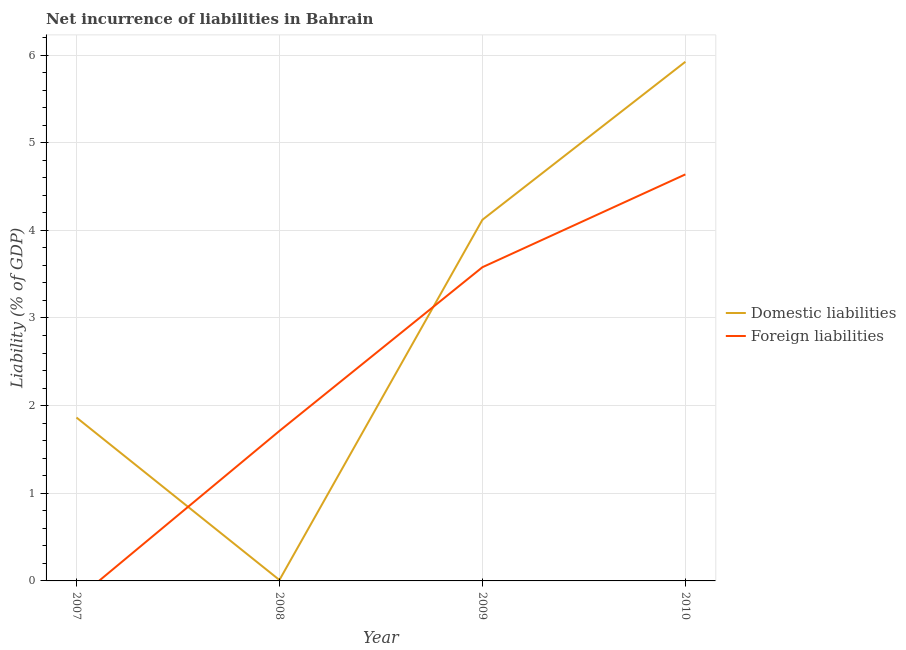How many different coloured lines are there?
Make the answer very short. 2. Does the line corresponding to incurrence of foreign liabilities intersect with the line corresponding to incurrence of domestic liabilities?
Your response must be concise. Yes. Is the number of lines equal to the number of legend labels?
Your response must be concise. No. What is the incurrence of domestic liabilities in 2007?
Provide a short and direct response. 1.86. Across all years, what is the maximum incurrence of domestic liabilities?
Offer a terse response. 5.92. Across all years, what is the minimum incurrence of domestic liabilities?
Your answer should be compact. 0.01. In which year was the incurrence of domestic liabilities maximum?
Ensure brevity in your answer.  2010. What is the total incurrence of domestic liabilities in the graph?
Your answer should be very brief. 11.92. What is the difference between the incurrence of foreign liabilities in 2009 and that in 2010?
Your answer should be very brief. -1.06. What is the difference between the incurrence of foreign liabilities in 2007 and the incurrence of domestic liabilities in 2010?
Offer a terse response. -5.92. What is the average incurrence of foreign liabilities per year?
Ensure brevity in your answer.  2.48. In the year 2010, what is the difference between the incurrence of foreign liabilities and incurrence of domestic liabilities?
Offer a terse response. -1.29. In how many years, is the incurrence of domestic liabilities greater than 1.4 %?
Provide a short and direct response. 3. What is the ratio of the incurrence of domestic liabilities in 2009 to that in 2010?
Your answer should be compact. 0.7. Is the incurrence of domestic liabilities in 2008 less than that in 2010?
Your response must be concise. Yes. Is the difference between the incurrence of domestic liabilities in 2009 and 2010 greater than the difference between the incurrence of foreign liabilities in 2009 and 2010?
Provide a succinct answer. No. What is the difference between the highest and the second highest incurrence of foreign liabilities?
Offer a very short reply. 1.06. What is the difference between the highest and the lowest incurrence of domestic liabilities?
Your answer should be compact. 5.91. Does the incurrence of domestic liabilities monotonically increase over the years?
Your answer should be compact. No. How many lines are there?
Your answer should be very brief. 2. How many years are there in the graph?
Offer a very short reply. 4. What is the difference between two consecutive major ticks on the Y-axis?
Your answer should be compact. 1. Does the graph contain any zero values?
Offer a very short reply. Yes. Where does the legend appear in the graph?
Your answer should be very brief. Center right. How are the legend labels stacked?
Offer a terse response. Vertical. What is the title of the graph?
Your answer should be compact. Net incurrence of liabilities in Bahrain. What is the label or title of the X-axis?
Provide a short and direct response. Year. What is the label or title of the Y-axis?
Provide a short and direct response. Liability (% of GDP). What is the Liability (% of GDP) of Domestic liabilities in 2007?
Offer a very short reply. 1.86. What is the Liability (% of GDP) of Foreign liabilities in 2007?
Provide a succinct answer. 0. What is the Liability (% of GDP) in Domestic liabilities in 2008?
Give a very brief answer. 0.01. What is the Liability (% of GDP) in Foreign liabilities in 2008?
Make the answer very short. 1.71. What is the Liability (% of GDP) of Domestic liabilities in 2009?
Make the answer very short. 4.12. What is the Liability (% of GDP) in Foreign liabilities in 2009?
Your response must be concise. 3.58. What is the Liability (% of GDP) in Domestic liabilities in 2010?
Provide a succinct answer. 5.92. What is the Liability (% of GDP) of Foreign liabilities in 2010?
Give a very brief answer. 4.64. Across all years, what is the maximum Liability (% of GDP) in Domestic liabilities?
Offer a terse response. 5.92. Across all years, what is the maximum Liability (% of GDP) of Foreign liabilities?
Your response must be concise. 4.64. Across all years, what is the minimum Liability (% of GDP) of Domestic liabilities?
Provide a short and direct response. 0.01. What is the total Liability (% of GDP) in Domestic liabilities in the graph?
Ensure brevity in your answer.  11.92. What is the total Liability (% of GDP) in Foreign liabilities in the graph?
Offer a very short reply. 9.93. What is the difference between the Liability (% of GDP) in Domestic liabilities in 2007 and that in 2008?
Give a very brief answer. 1.85. What is the difference between the Liability (% of GDP) of Domestic liabilities in 2007 and that in 2009?
Your answer should be very brief. -2.26. What is the difference between the Liability (% of GDP) of Domestic liabilities in 2007 and that in 2010?
Your response must be concise. -4.06. What is the difference between the Liability (% of GDP) in Domestic liabilities in 2008 and that in 2009?
Provide a succinct answer. -4.11. What is the difference between the Liability (% of GDP) in Foreign liabilities in 2008 and that in 2009?
Offer a terse response. -1.87. What is the difference between the Liability (% of GDP) in Domestic liabilities in 2008 and that in 2010?
Keep it short and to the point. -5.91. What is the difference between the Liability (% of GDP) in Foreign liabilities in 2008 and that in 2010?
Offer a very short reply. -2.93. What is the difference between the Liability (% of GDP) of Domestic liabilities in 2009 and that in 2010?
Your answer should be compact. -1.8. What is the difference between the Liability (% of GDP) in Foreign liabilities in 2009 and that in 2010?
Provide a succinct answer. -1.06. What is the difference between the Liability (% of GDP) of Domestic liabilities in 2007 and the Liability (% of GDP) of Foreign liabilities in 2008?
Ensure brevity in your answer.  0.15. What is the difference between the Liability (% of GDP) of Domestic liabilities in 2007 and the Liability (% of GDP) of Foreign liabilities in 2009?
Provide a succinct answer. -1.71. What is the difference between the Liability (% of GDP) in Domestic liabilities in 2007 and the Liability (% of GDP) in Foreign liabilities in 2010?
Keep it short and to the point. -2.77. What is the difference between the Liability (% of GDP) in Domestic liabilities in 2008 and the Liability (% of GDP) in Foreign liabilities in 2009?
Your response must be concise. -3.57. What is the difference between the Liability (% of GDP) of Domestic liabilities in 2008 and the Liability (% of GDP) of Foreign liabilities in 2010?
Keep it short and to the point. -4.63. What is the difference between the Liability (% of GDP) in Domestic liabilities in 2009 and the Liability (% of GDP) in Foreign liabilities in 2010?
Offer a very short reply. -0.52. What is the average Liability (% of GDP) in Domestic liabilities per year?
Provide a succinct answer. 2.98. What is the average Liability (% of GDP) of Foreign liabilities per year?
Offer a terse response. 2.48. In the year 2008, what is the difference between the Liability (% of GDP) of Domestic liabilities and Liability (% of GDP) of Foreign liabilities?
Ensure brevity in your answer.  -1.7. In the year 2009, what is the difference between the Liability (% of GDP) in Domestic liabilities and Liability (% of GDP) in Foreign liabilities?
Keep it short and to the point. 0.54. In the year 2010, what is the difference between the Liability (% of GDP) in Domestic liabilities and Liability (% of GDP) in Foreign liabilities?
Offer a very short reply. 1.29. What is the ratio of the Liability (% of GDP) of Domestic liabilities in 2007 to that in 2008?
Give a very brief answer. 173.3. What is the ratio of the Liability (% of GDP) of Domestic liabilities in 2007 to that in 2009?
Your answer should be compact. 0.45. What is the ratio of the Liability (% of GDP) of Domestic liabilities in 2007 to that in 2010?
Your answer should be compact. 0.31. What is the ratio of the Liability (% of GDP) in Domestic liabilities in 2008 to that in 2009?
Give a very brief answer. 0. What is the ratio of the Liability (% of GDP) of Foreign liabilities in 2008 to that in 2009?
Provide a short and direct response. 0.48. What is the ratio of the Liability (% of GDP) in Domestic liabilities in 2008 to that in 2010?
Your answer should be very brief. 0. What is the ratio of the Liability (% of GDP) of Foreign liabilities in 2008 to that in 2010?
Your answer should be compact. 0.37. What is the ratio of the Liability (% of GDP) in Domestic liabilities in 2009 to that in 2010?
Offer a terse response. 0.7. What is the ratio of the Liability (% of GDP) of Foreign liabilities in 2009 to that in 2010?
Your answer should be compact. 0.77. What is the difference between the highest and the second highest Liability (% of GDP) of Domestic liabilities?
Keep it short and to the point. 1.8. What is the difference between the highest and the second highest Liability (% of GDP) in Foreign liabilities?
Your answer should be very brief. 1.06. What is the difference between the highest and the lowest Liability (% of GDP) of Domestic liabilities?
Offer a terse response. 5.91. What is the difference between the highest and the lowest Liability (% of GDP) in Foreign liabilities?
Ensure brevity in your answer.  4.64. 